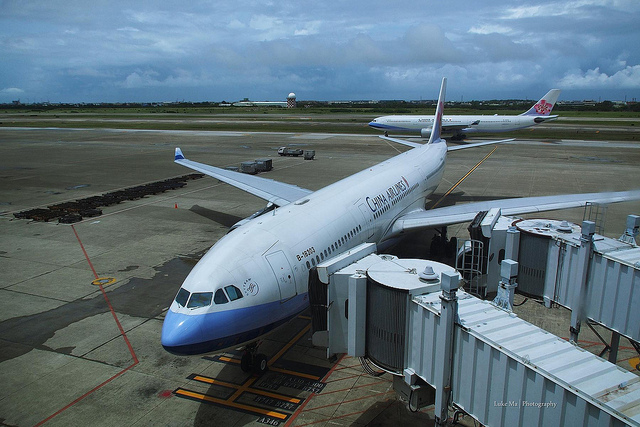Identify and read out the text in this image. B-BIA China ARIAJ Photography 